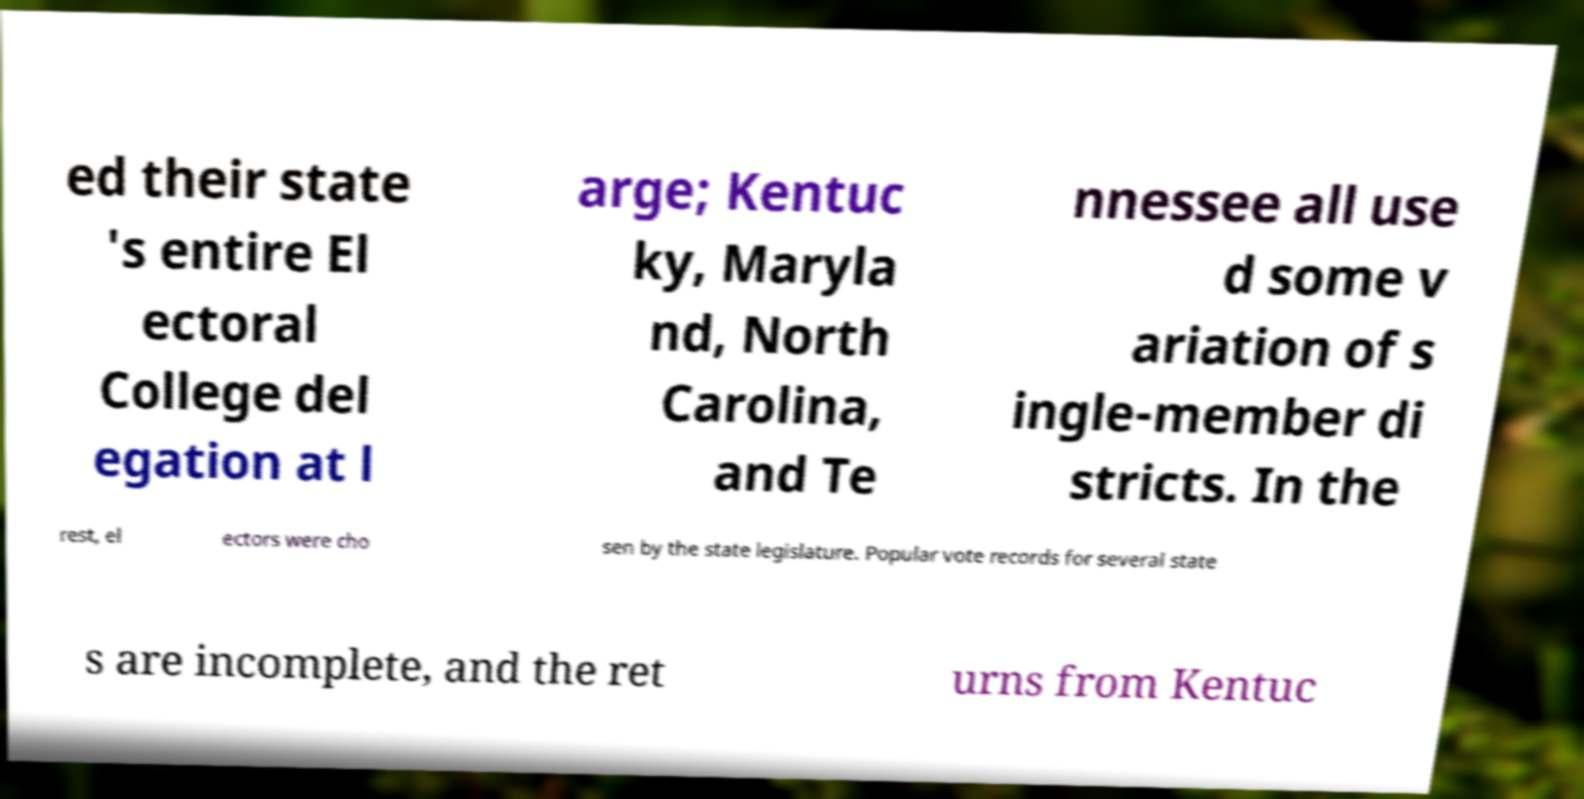Can you accurately transcribe the text from the provided image for me? ed their state 's entire El ectoral College del egation at l arge; Kentuc ky, Maryla nd, North Carolina, and Te nnessee all use d some v ariation of s ingle-member di stricts. In the rest, el ectors were cho sen by the state legislature. Popular vote records for several state s are incomplete, and the ret urns from Kentuc 